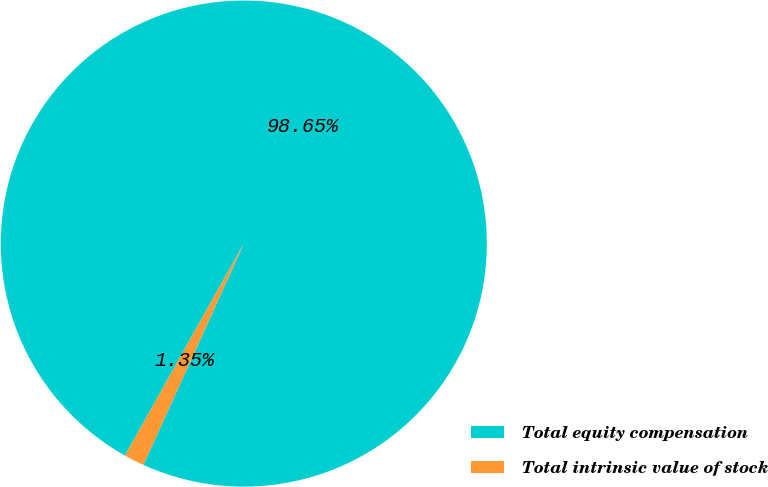Convert chart. <chart><loc_0><loc_0><loc_500><loc_500><pie_chart><fcel>Total equity compensation<fcel>Total intrinsic value of stock<nl><fcel>98.65%<fcel>1.35%<nl></chart> 